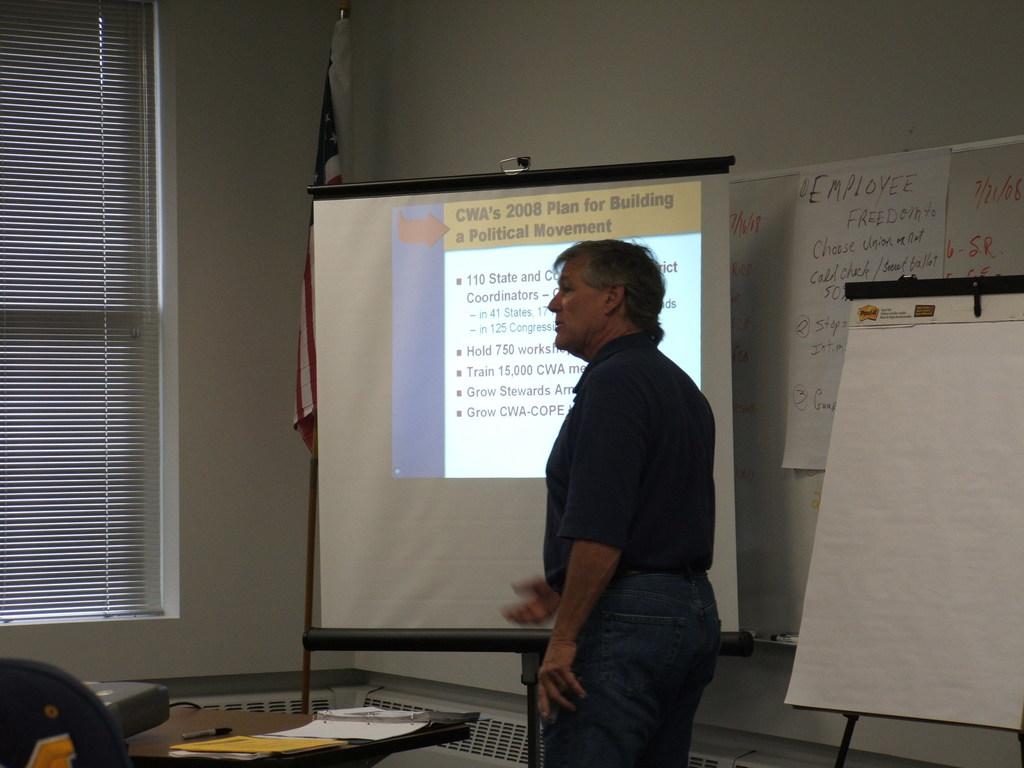What year is the plan for building?
Provide a short and direct response. 2008. What is at the top of the projector in the yellow box?
Provide a short and direct response. Cwa's 2008 plan for building a political movement . 